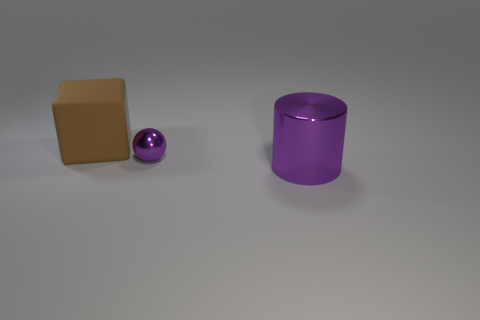What material is the purple object behind the big object right of the big thing behind the purple cylinder made of?
Your response must be concise. Metal. Are there fewer large brown objects in front of the tiny sphere than big purple metal cylinders?
Your answer should be very brief. Yes. There is a block that is the same size as the cylinder; what material is it?
Give a very brief answer. Rubber. How many objects are either large cubes or purple things that are in front of the tiny purple object?
Your response must be concise. 2. What is the shape of the large rubber object?
Your answer should be very brief. Cube. The big object that is behind the metal object left of the large purple thing is what shape?
Provide a succinct answer. Cube. There is a tiny object that is the same color as the metallic cylinder; what is its material?
Provide a short and direct response. Metal. There is a ball that is made of the same material as the large purple cylinder; what color is it?
Make the answer very short. Purple. Is there any other thing that has the same size as the metallic sphere?
Offer a terse response. No. Is the color of the object in front of the tiny purple metallic thing the same as the shiny object that is to the left of the purple metallic cylinder?
Keep it short and to the point. Yes. 